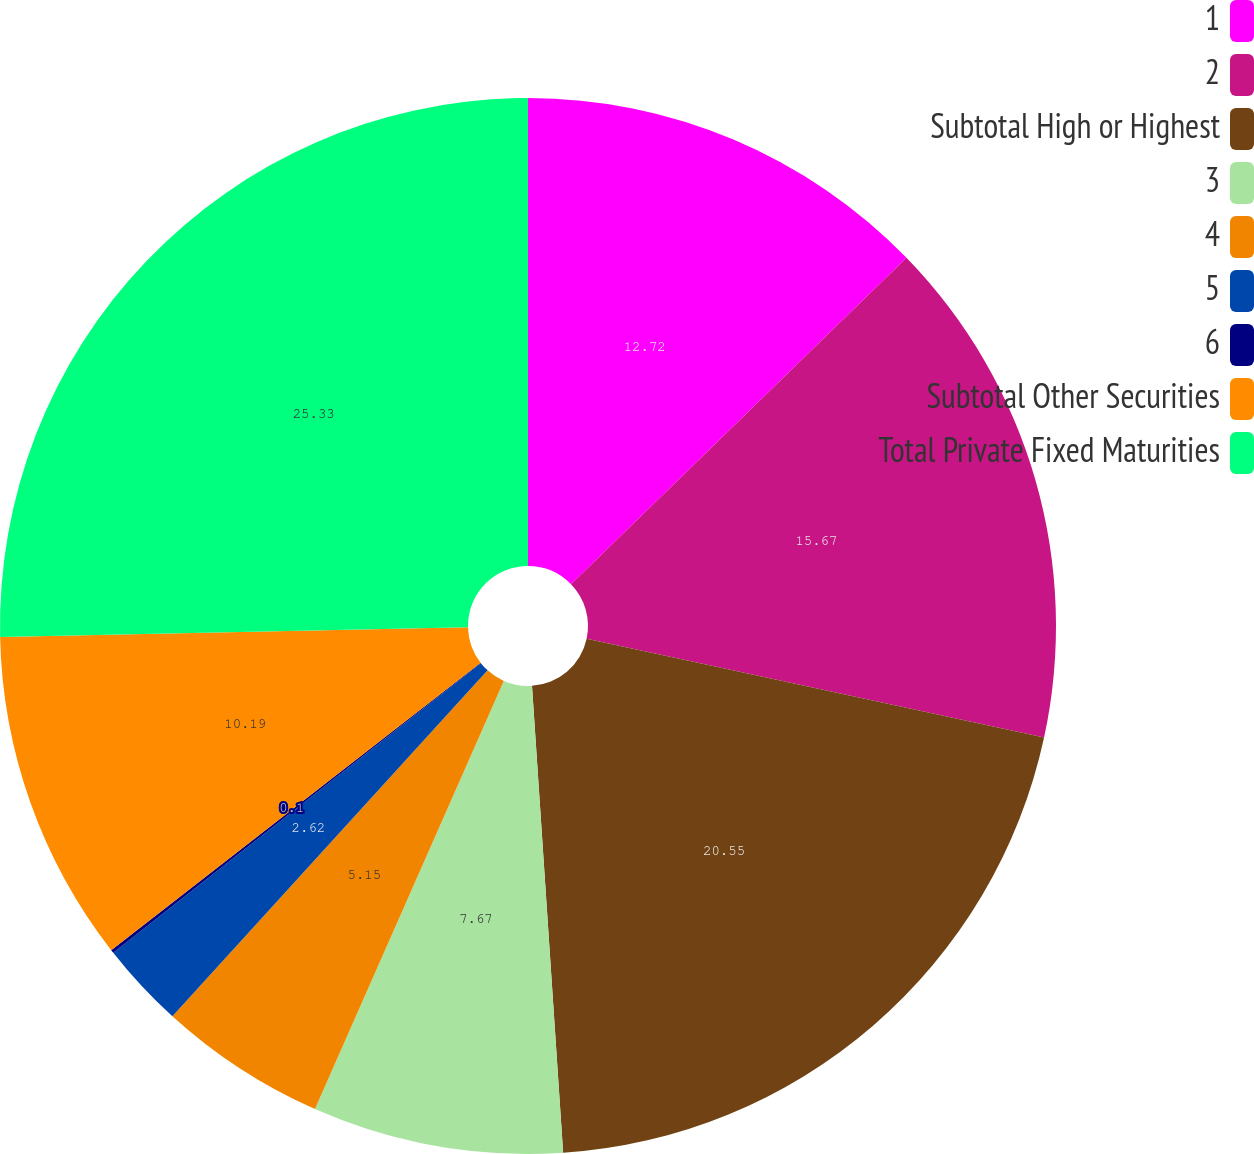Convert chart. <chart><loc_0><loc_0><loc_500><loc_500><pie_chart><fcel>1<fcel>2<fcel>Subtotal High or Highest<fcel>3<fcel>4<fcel>5<fcel>6<fcel>Subtotal Other Securities<fcel>Total Private Fixed Maturities<nl><fcel>12.72%<fcel>15.67%<fcel>20.55%<fcel>7.67%<fcel>5.15%<fcel>2.62%<fcel>0.1%<fcel>10.19%<fcel>25.33%<nl></chart> 